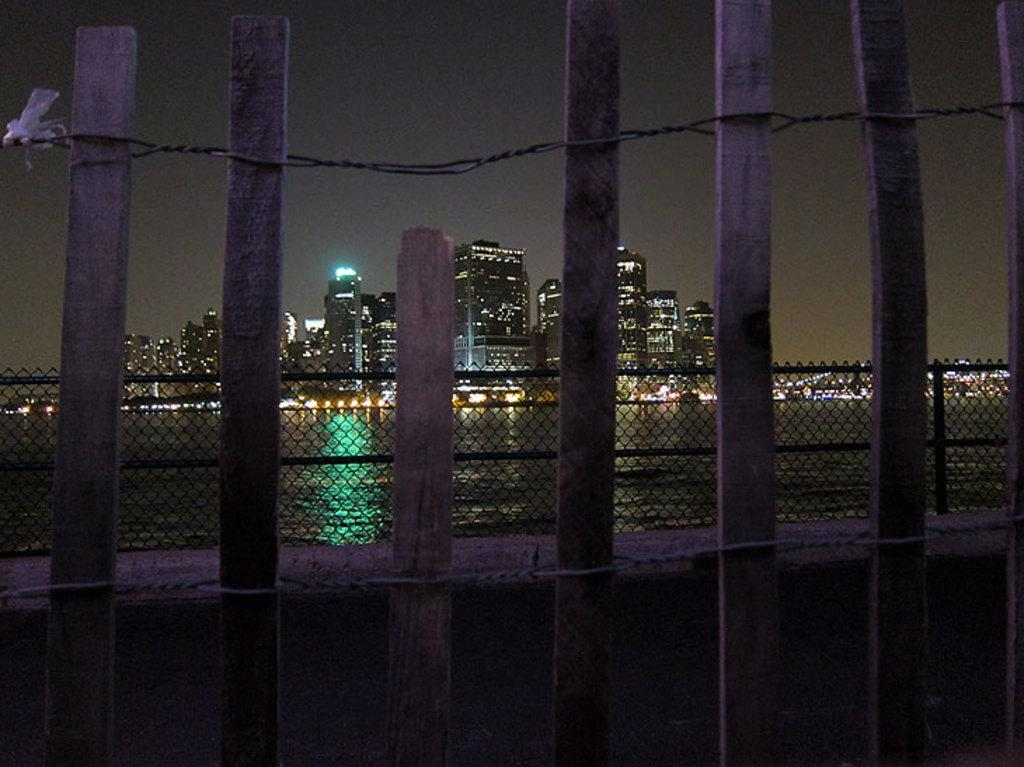What type of fence is in the foreground of the image? There is a wooden fence in the image. What is behind the wooden fence? There is a net fence behind the wooden fence. What natural feature can be seen in the image? There is a river visible in the image. What can be seen in the distance in the image? There are buildings and the sky visible in the background of the image. What is the weight of the fly that is visible in the image? There is no fly present in the image, so it is not possible to determine its weight. 